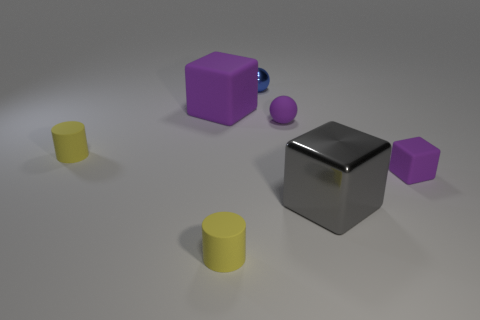How many other large blocks are made of the same material as the large purple cube?
Make the answer very short. 0. What size is the ball behind the purple block that is left of the gray metal thing on the right side of the tiny blue metallic sphere?
Offer a terse response. Small. How many small rubber balls are behind the big rubber block?
Your answer should be very brief. 0. Are there more large metallic blocks than large brown balls?
Your response must be concise. Yes. There is a matte sphere that is the same color as the tiny rubber block; what is its size?
Your answer should be very brief. Small. There is a thing that is both in front of the small purple cube and on the right side of the purple ball; what is its size?
Give a very brief answer. Large. The large block that is in front of the thing that is on the left side of the large block to the left of the tiny blue sphere is made of what material?
Your response must be concise. Metal. What material is the other cube that is the same color as the tiny rubber block?
Your response must be concise. Rubber. There is a sphere on the right side of the blue shiny object; does it have the same color as the cube that is on the right side of the large gray metallic block?
Provide a short and direct response. Yes. The tiny thing that is behind the big rubber thing left of the yellow rubber object that is on the right side of the big rubber object is what shape?
Ensure brevity in your answer.  Sphere. 